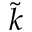<formula> <loc_0><loc_0><loc_500><loc_500>\tilde { k }</formula> 